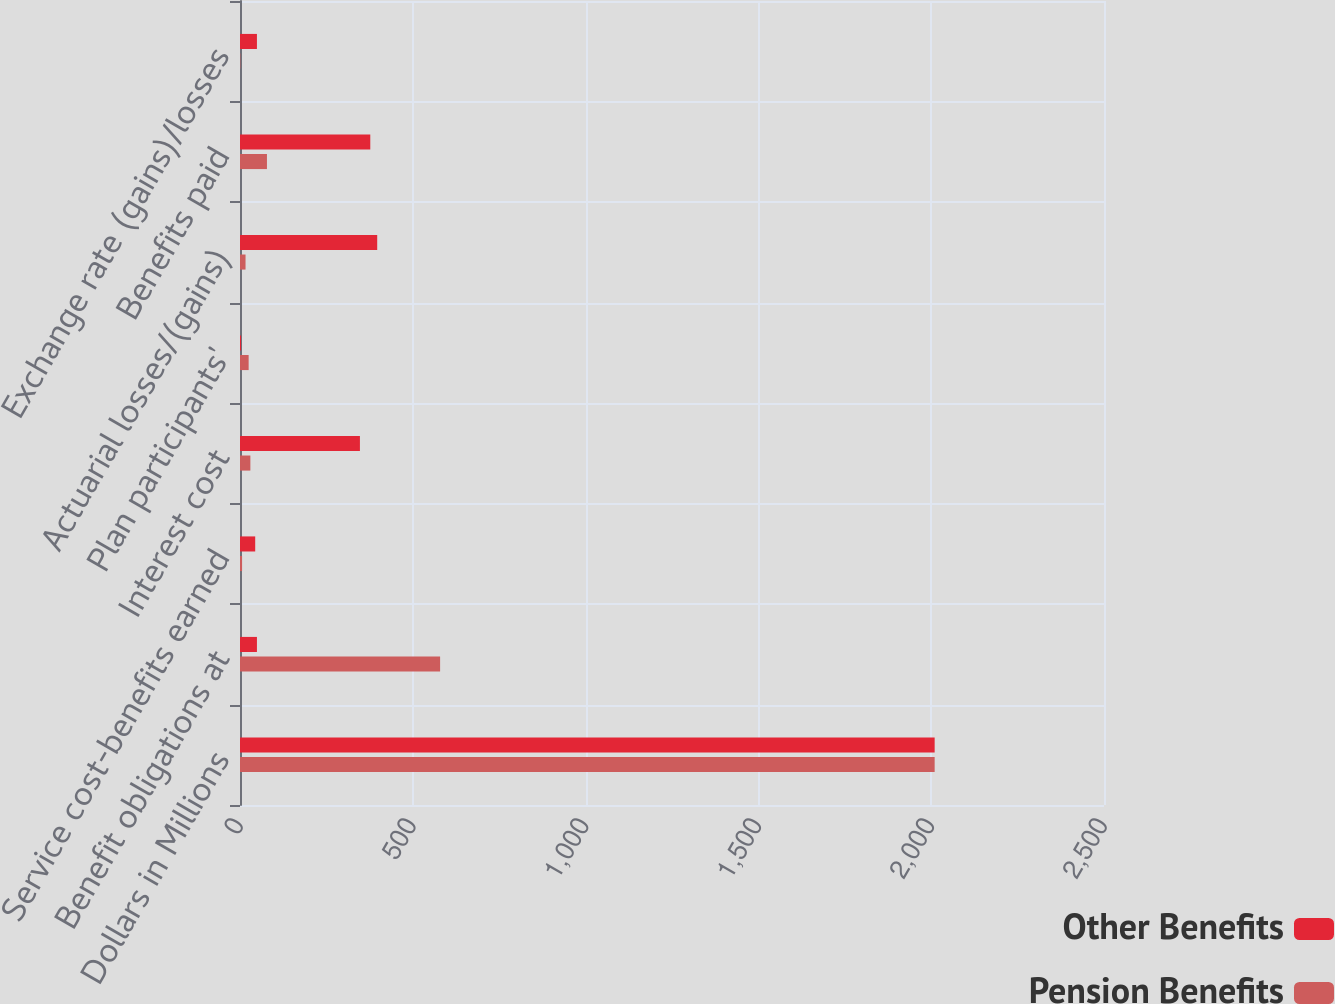<chart> <loc_0><loc_0><loc_500><loc_500><stacked_bar_chart><ecel><fcel>Dollars in Millions<fcel>Benefit obligations at<fcel>Service cost-benefits earned<fcel>Interest cost<fcel>Plan participants'<fcel>Actuarial losses/(gains)<fcel>Benefits paid<fcel>Exchange rate (gains)/losses<nl><fcel>Other Benefits<fcel>2010<fcel>49<fcel>44<fcel>347<fcel>3<fcel>397<fcel>377<fcel>49<nl><fcel>Pension Benefits<fcel>2010<fcel>579<fcel>6<fcel>30<fcel>25<fcel>16<fcel>78<fcel>1<nl></chart> 